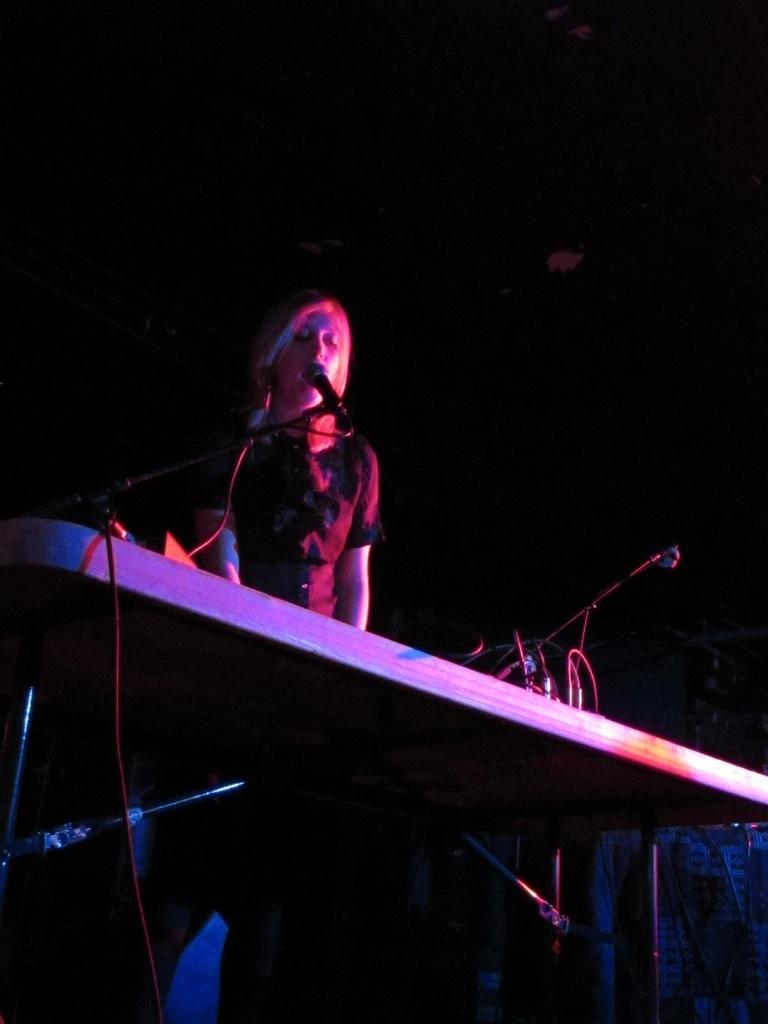Can you describe this image briefly? The image is dark but we can see a woman is standing at the table. On the table there are cables,mic on stand and other objects. 